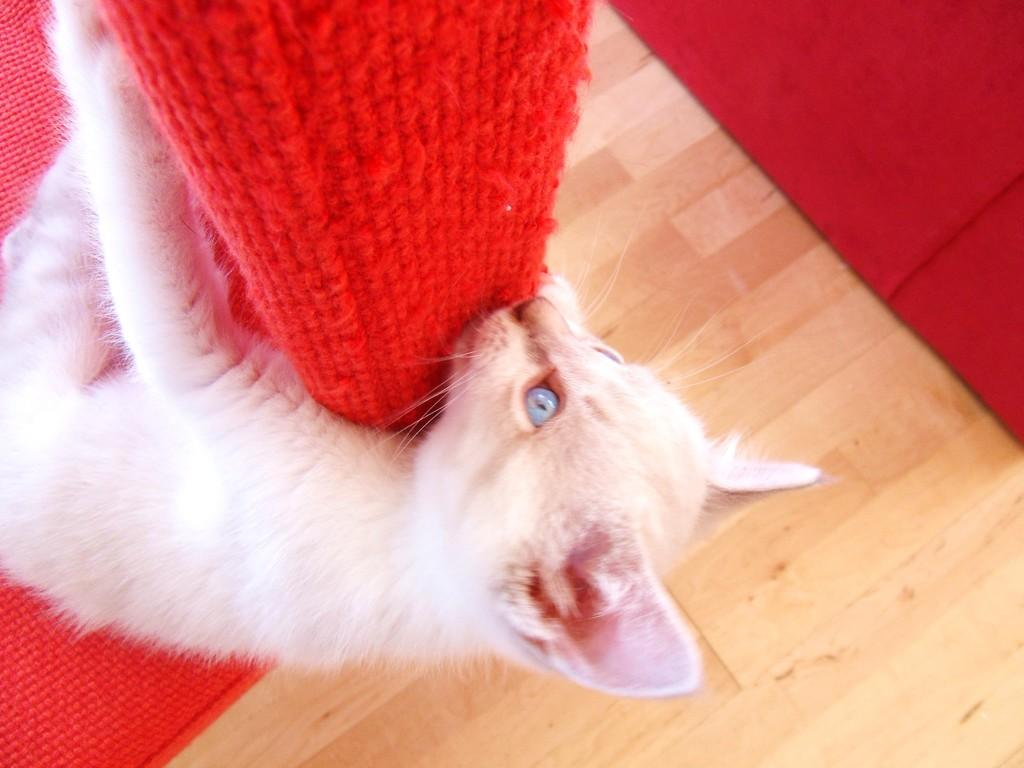What animal is present in the image? There is a cat in the image. What is the cat holding in its paws? The cat is holding a mat. What color is the cat? The cat appears to be red in color. What type of surface is visible in the image? There is a floor visible in the image. Are there any other mats present in the image? Yes, there is another mat lying on the floor on the right side of the image. What type of holiday is being celebrated in the image? There is no indication of a holiday being celebrated in the image. What type of wood is the cat made of? The cat is not made of wood; it is a living animal. What type of machine is being used by the cat in the image? There is no machine present in the image; the cat is holding a mat. 